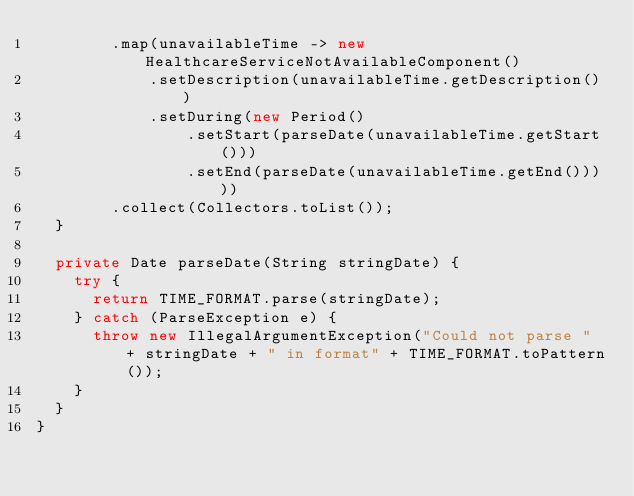Convert code to text. <code><loc_0><loc_0><loc_500><loc_500><_Java_>        .map(unavailableTime -> new HealthcareServiceNotAvailableComponent()
            .setDescription(unavailableTime.getDescription())
            .setDuring(new Period()
                .setStart(parseDate(unavailableTime.getStart()))
                .setEnd(parseDate(unavailableTime.getEnd()))))
        .collect(Collectors.toList());
  }

  private Date parseDate(String stringDate) {
    try {
      return TIME_FORMAT.parse(stringDate);
    } catch (ParseException e) {
      throw new IllegalArgumentException("Could not parse " + stringDate + " in format" + TIME_FORMAT.toPattern());
    }
  }
}
</code> 